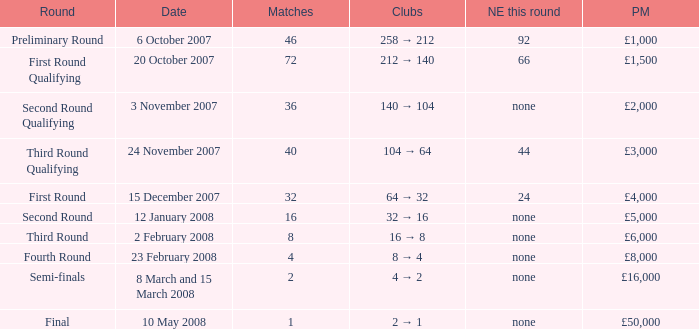What is the average for matches with a prize money amount of £3,000? 40.0. 